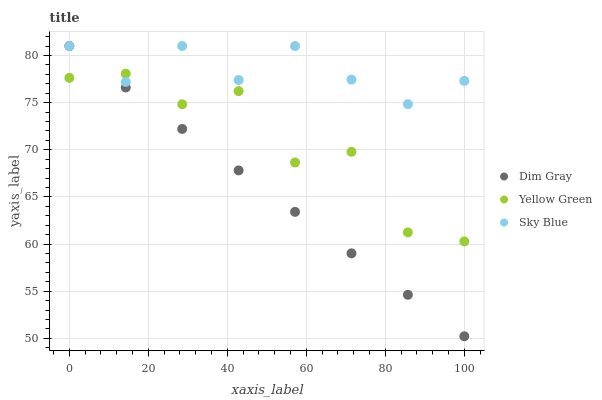Does Dim Gray have the minimum area under the curve?
Answer yes or no. Yes. Does Sky Blue have the maximum area under the curve?
Answer yes or no. Yes. Does Yellow Green have the minimum area under the curve?
Answer yes or no. No. Does Yellow Green have the maximum area under the curve?
Answer yes or no. No. Is Dim Gray the smoothest?
Answer yes or no. Yes. Is Yellow Green the roughest?
Answer yes or no. Yes. Is Yellow Green the smoothest?
Answer yes or no. No. Is Dim Gray the roughest?
Answer yes or no. No. Does Dim Gray have the lowest value?
Answer yes or no. Yes. Does Yellow Green have the lowest value?
Answer yes or no. No. Does Dim Gray have the highest value?
Answer yes or no. Yes. Does Yellow Green have the highest value?
Answer yes or no. No. Does Dim Gray intersect Yellow Green?
Answer yes or no. Yes. Is Dim Gray less than Yellow Green?
Answer yes or no. No. Is Dim Gray greater than Yellow Green?
Answer yes or no. No. 